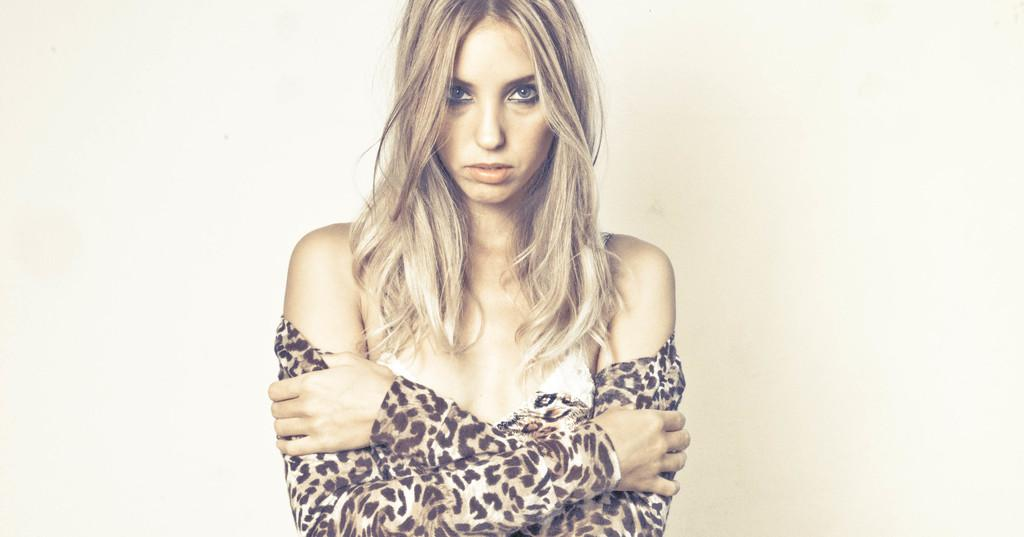Who is present in the image? There is a woman in the image. What is the woman wearing? The woman is wearing a brown and white colored dress. What color is the background of the image? The background of the image is white. Is there a boy operating a station in the image? There is no boy or station present in the image; it features a woman wearing a brown and white colored dress against a white background. 